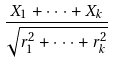<formula> <loc_0><loc_0><loc_500><loc_500>\frac { X _ { 1 } + \cdot \cdot \cdot + X _ { k } } { \sqrt { r _ { 1 } ^ { 2 } + \cdot \cdot \cdot + r _ { k } ^ { 2 } } }</formula> 